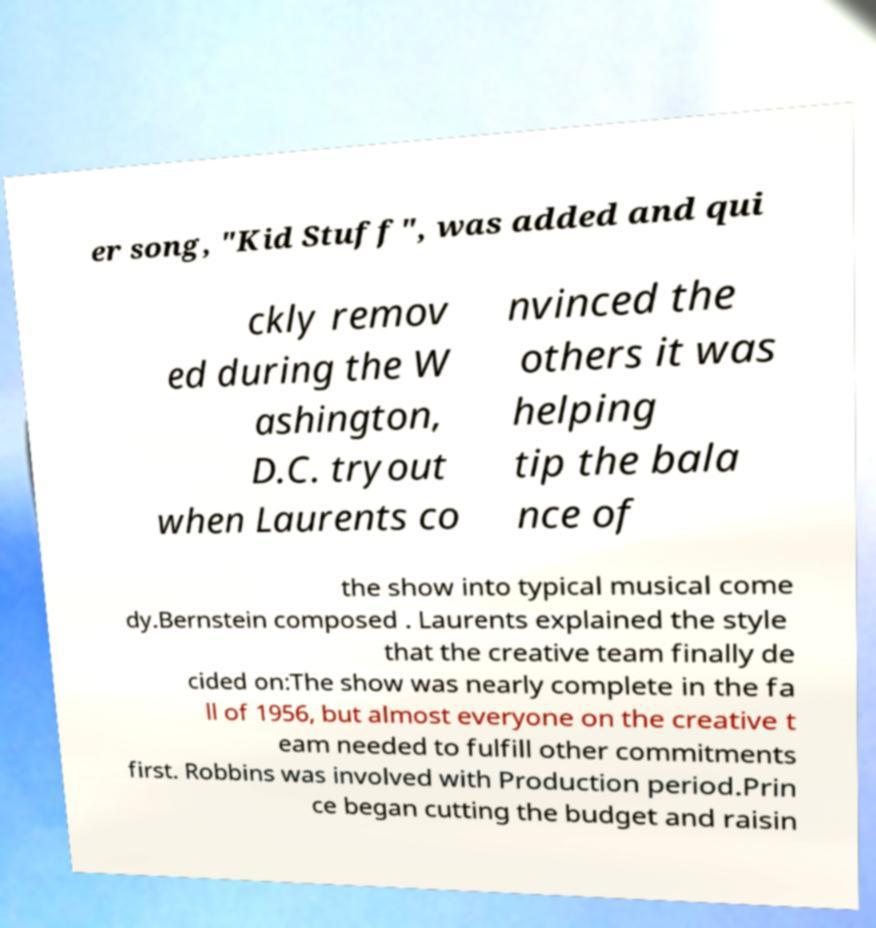Can you accurately transcribe the text from the provided image for me? er song, "Kid Stuff", was added and qui ckly remov ed during the W ashington, D.C. tryout when Laurents co nvinced the others it was helping tip the bala nce of the show into typical musical come dy.Bernstein composed . Laurents explained the style that the creative team finally de cided on:The show was nearly complete in the fa ll of 1956, but almost everyone on the creative t eam needed to fulfill other commitments first. Robbins was involved with Production period.Prin ce began cutting the budget and raisin 